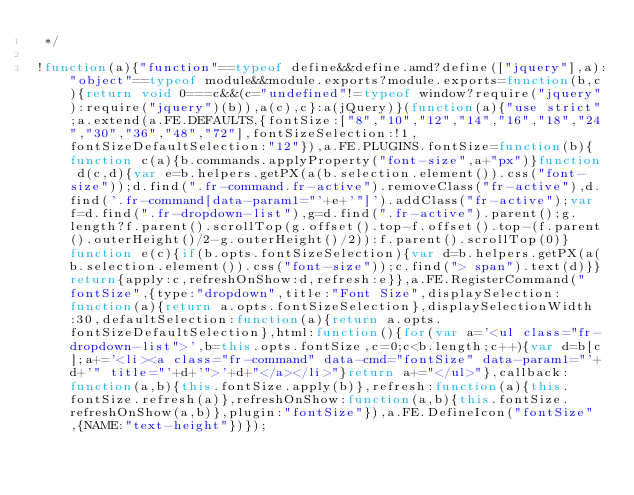<code> <loc_0><loc_0><loc_500><loc_500><_JavaScript_> */

!function(a){"function"==typeof define&&define.amd?define(["jquery"],a):"object"==typeof module&&module.exports?module.exports=function(b,c){return void 0===c&&(c="undefined"!=typeof window?require("jquery"):require("jquery")(b)),a(c),c}:a(jQuery)}(function(a){"use strict";a.extend(a.FE.DEFAULTS,{fontSize:["8","10","12","14","16","18","24","30","36","48","72"],fontSizeSelection:!1,fontSizeDefaultSelection:"12"}),a.FE.PLUGINS.fontSize=function(b){function c(a){b.commands.applyProperty("font-size",a+"px")}function d(c,d){var e=b.helpers.getPX(a(b.selection.element()).css("font-size"));d.find(".fr-command.fr-active").removeClass("fr-active"),d.find('.fr-command[data-param1="'+e+'"]').addClass("fr-active");var f=d.find(".fr-dropdown-list"),g=d.find(".fr-active").parent();g.length?f.parent().scrollTop(g.offset().top-f.offset().top-(f.parent().outerHeight()/2-g.outerHeight()/2)):f.parent().scrollTop(0)}function e(c){if(b.opts.fontSizeSelection){var d=b.helpers.getPX(a(b.selection.element()).css("font-size"));c.find("> span").text(d)}}return{apply:c,refreshOnShow:d,refresh:e}},a.FE.RegisterCommand("fontSize",{type:"dropdown",title:"Font Size",displaySelection:function(a){return a.opts.fontSizeSelection},displaySelectionWidth:30,defaultSelection:function(a){return a.opts.fontSizeDefaultSelection},html:function(){for(var a='<ul class="fr-dropdown-list">',b=this.opts.fontSize,c=0;c<b.length;c++){var d=b[c];a+='<li><a class="fr-command" data-cmd="fontSize" data-param1="'+d+'" title="'+d+'">'+d+"</a></li>"}return a+="</ul>"},callback:function(a,b){this.fontSize.apply(b)},refresh:function(a){this.fontSize.refresh(a)},refreshOnShow:function(a,b){this.fontSize.refreshOnShow(a,b)},plugin:"fontSize"}),a.FE.DefineIcon("fontSize",{NAME:"text-height"})});</code> 